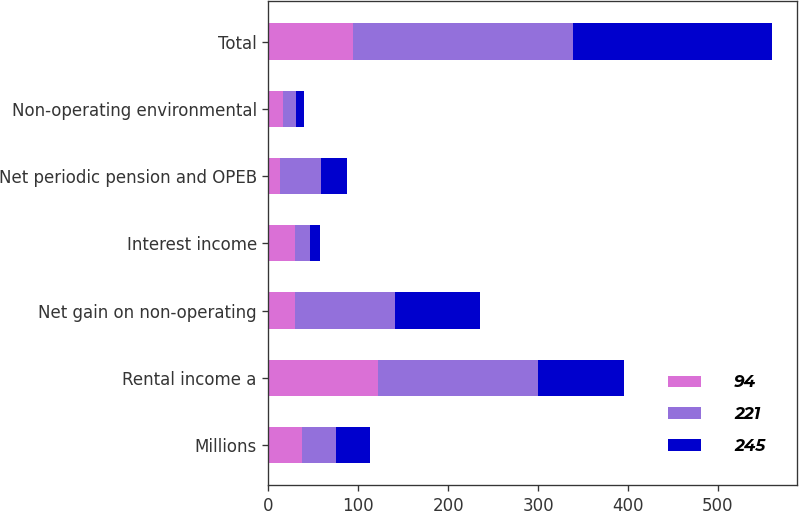Convert chart to OTSL. <chart><loc_0><loc_0><loc_500><loc_500><stacked_bar_chart><ecel><fcel>Millions<fcel>Rental income a<fcel>Net gain on non-operating<fcel>Interest income<fcel>Net periodic pension and OPEB<fcel>Non-operating environmental<fcel>Total<nl><fcel>94<fcel>37.5<fcel>122<fcel>30<fcel>30<fcel>13<fcel>16<fcel>94<nl><fcel>221<fcel>37.5<fcel>178<fcel>111<fcel>16<fcel>45<fcel>15<fcel>245<nl><fcel>245<fcel>37.5<fcel>96<fcel>94<fcel>11<fcel>29<fcel>9<fcel>221<nl></chart> 